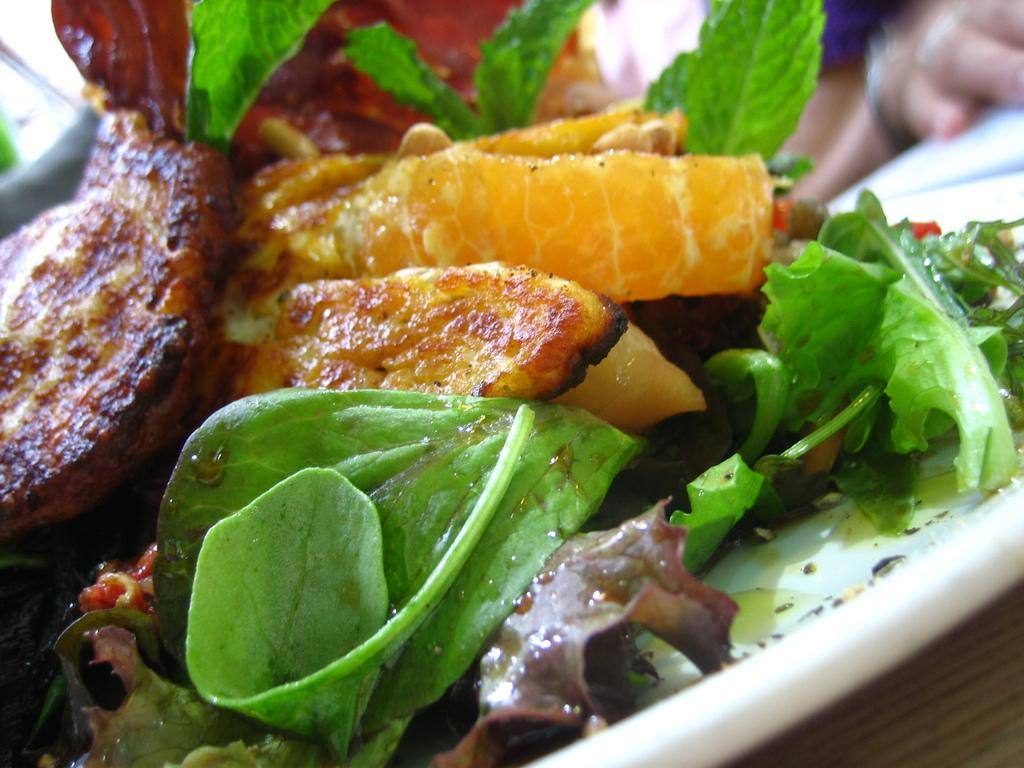What is on the plate that is visible in the image? There are food items on a plate in the image. Where is the plate located in the image? The plate is placed on a table. Can you describe anything about the person in the image? There is a hand of a person visible in the background. How would you describe the overall clarity of the image? The background of the image is slightly blurred. What type of clover is growing on the plate in the image? There is no clover present on the plate in the image; it contains food items. What meal is being served on the plate in the image? The specific meal cannot be determined from the image, as only food items are visible on the plate. 